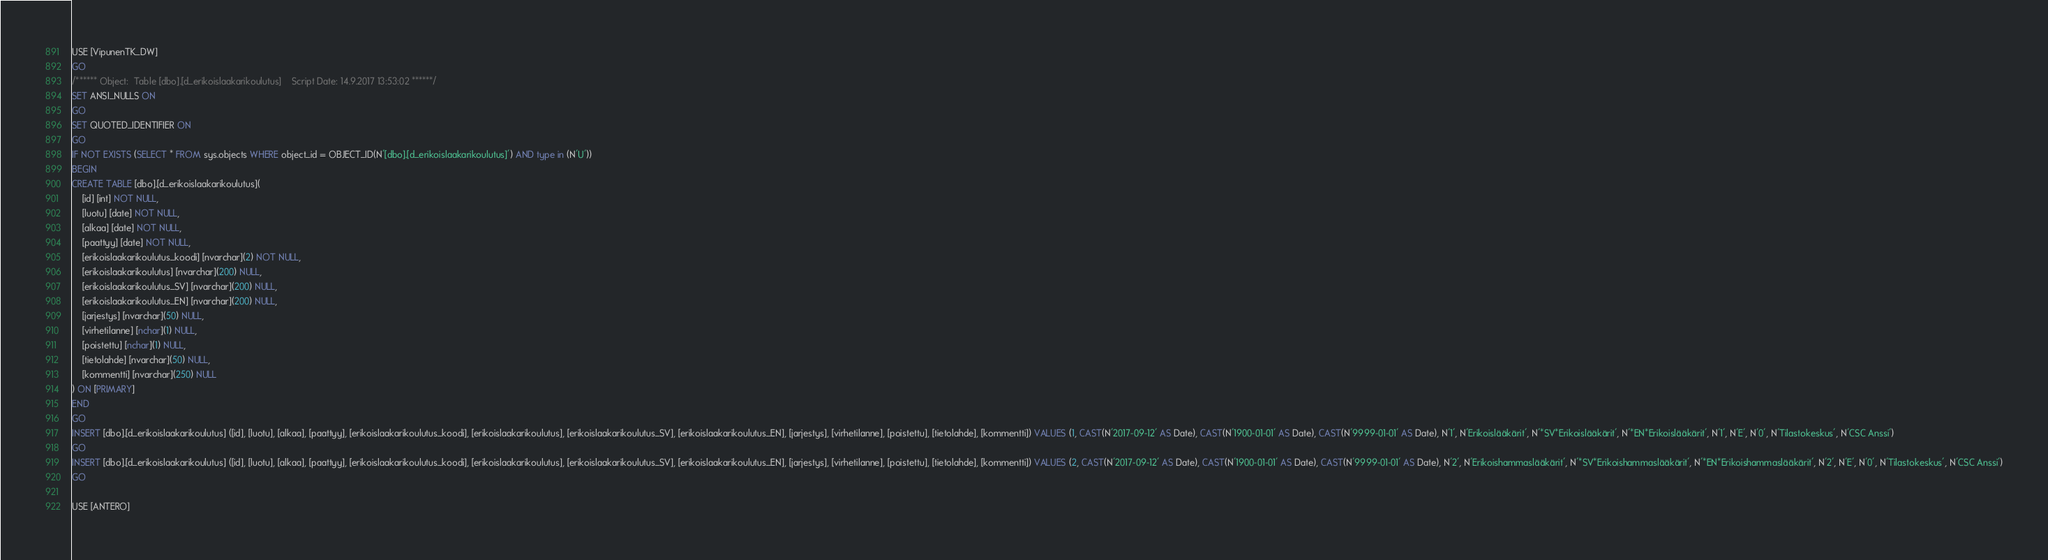<code> <loc_0><loc_0><loc_500><loc_500><_SQL_>USE [VipunenTK_DW]
GO
/****** Object:  Table [dbo].[d_erikoislaakarikoulutus]    Script Date: 14.9.2017 13:53:02 ******/
SET ANSI_NULLS ON
GO
SET QUOTED_IDENTIFIER ON
GO
IF NOT EXISTS (SELECT * FROM sys.objects WHERE object_id = OBJECT_ID(N'[dbo].[d_erikoislaakarikoulutus]') AND type in (N'U'))
BEGIN
CREATE TABLE [dbo].[d_erikoislaakarikoulutus](
	[id] [int] NOT NULL,
	[luotu] [date] NOT NULL,
	[alkaa] [date] NOT NULL,
	[paattyy] [date] NOT NULL,
	[erikoislaakarikoulutus_koodi] [nvarchar](2) NOT NULL,
	[erikoislaakarikoulutus] [nvarchar](200) NULL,
	[erikoislaakarikoulutus_SV] [nvarchar](200) NULL,
	[erikoislaakarikoulutus_EN] [nvarchar](200) NULL,
	[jarjestys] [nvarchar](50) NULL,
	[virhetilanne] [nchar](1) NULL,
	[poistettu] [nchar](1) NULL,
	[tietolahde] [nvarchar](50) NULL,
	[kommentti] [nvarchar](250) NULL
) ON [PRIMARY]
END
GO
INSERT [dbo].[d_erikoislaakarikoulutus] ([id], [luotu], [alkaa], [paattyy], [erikoislaakarikoulutus_koodi], [erikoislaakarikoulutus], [erikoislaakarikoulutus_SV], [erikoislaakarikoulutus_EN], [jarjestys], [virhetilanne], [poistettu], [tietolahde], [kommentti]) VALUES (1, CAST(N'2017-09-12' AS Date), CAST(N'1900-01-01' AS Date), CAST(N'9999-01-01' AS Date), N'1', N'Erikoislääkärit', N'*SV*Erikoislääkärit', N'*EN*Erikoislääkärit', N'1', N'E', N'0', N'Tilastokeskus', N'CSC Anssi')
GO
INSERT [dbo].[d_erikoislaakarikoulutus] ([id], [luotu], [alkaa], [paattyy], [erikoislaakarikoulutus_koodi], [erikoislaakarikoulutus], [erikoislaakarikoulutus_SV], [erikoislaakarikoulutus_EN], [jarjestys], [virhetilanne], [poistettu], [tietolahde], [kommentti]) VALUES (2, CAST(N'2017-09-12' AS Date), CAST(N'1900-01-01' AS Date), CAST(N'9999-01-01' AS Date), N'2', N'Erikoishammaslääkärit', N'*SV*Erikoishammaslääkärit', N'*EN*Erikoishammaslääkärit', N'2', N'E', N'0', N'Tilastokeskus', N'CSC Anssi')
GO

USE [ANTERO]</code> 